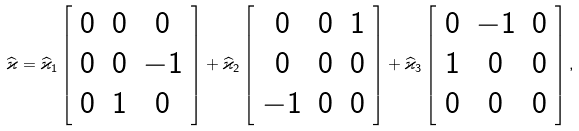Convert formula to latex. <formula><loc_0><loc_0><loc_500><loc_500>\widehat { \varkappa } = \widehat { \varkappa } _ { 1 } \left [ \begin{array} { c c c } 0 & 0 & 0 \\ 0 & 0 & - 1 \\ 0 & 1 & 0 \end{array} \right ] + \widehat { \varkappa } _ { 2 } \left [ \begin{array} { c c c } 0 & 0 & 1 \\ 0 & 0 & 0 \\ - 1 & 0 & 0 \end{array} \right ] + \widehat { \varkappa } _ { 3 } \left [ \begin{array} { c c c } 0 & - 1 & 0 \\ 1 & 0 & 0 \\ 0 & 0 & 0 \end{array} \right ] ,</formula> 